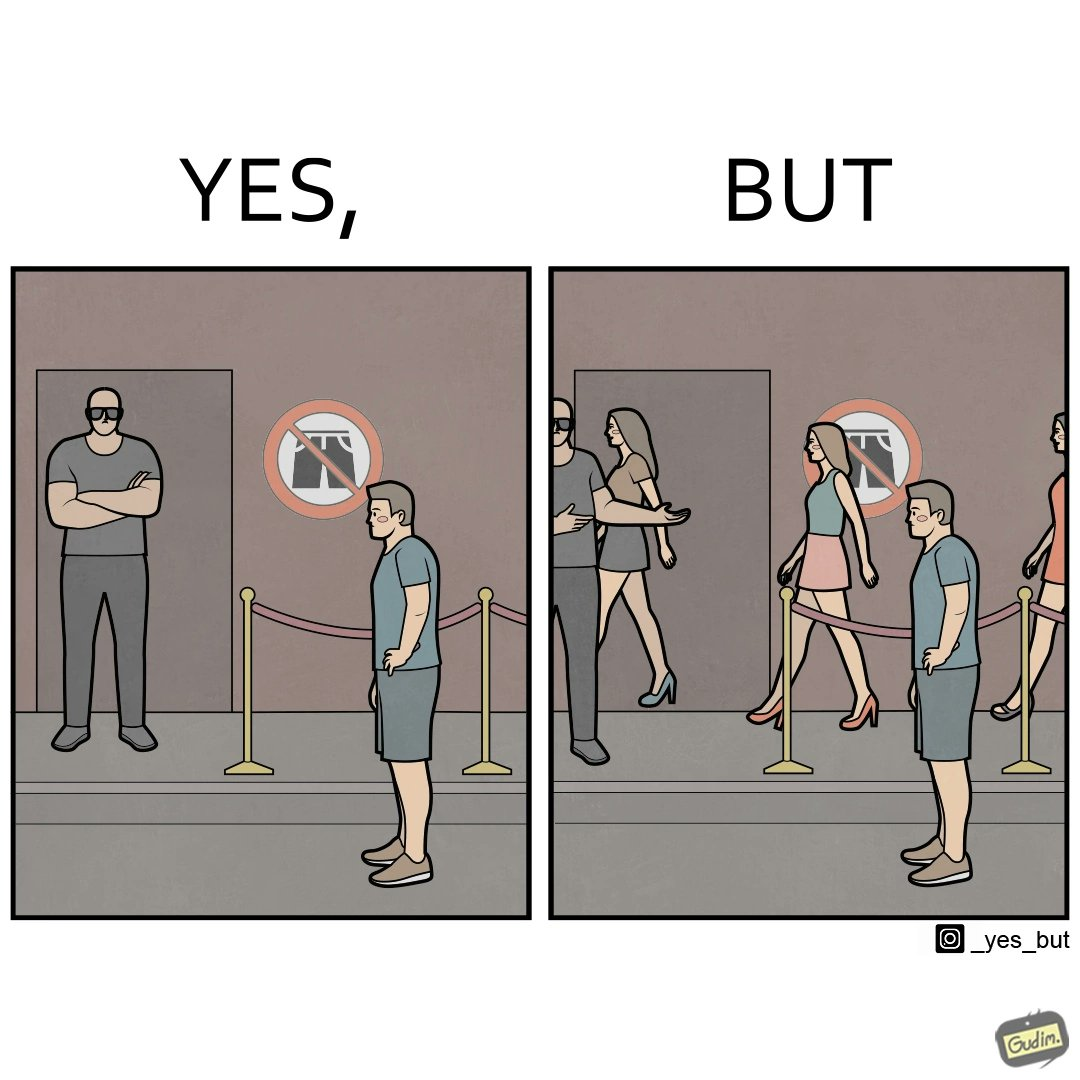What does this image depict? The image is ironic, because the same hotel which is not allowing the man to enter in shorts is allowing many girls to enter the hotel in shorts displaying the dual face of the hotel management 